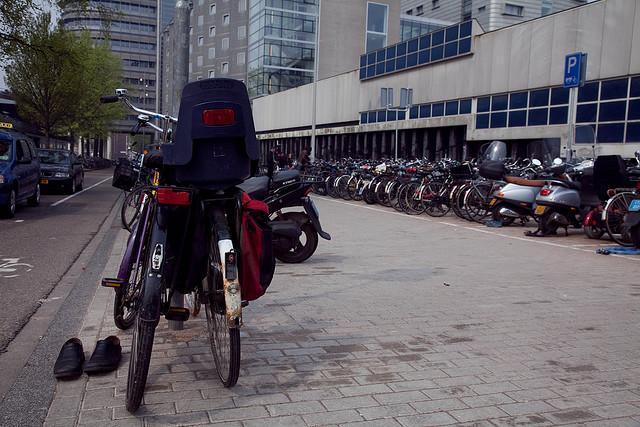How many bicycles are in the picture?
Give a very brief answer. 4. How many motorcycles are in the photo?
Give a very brief answer. 3. 